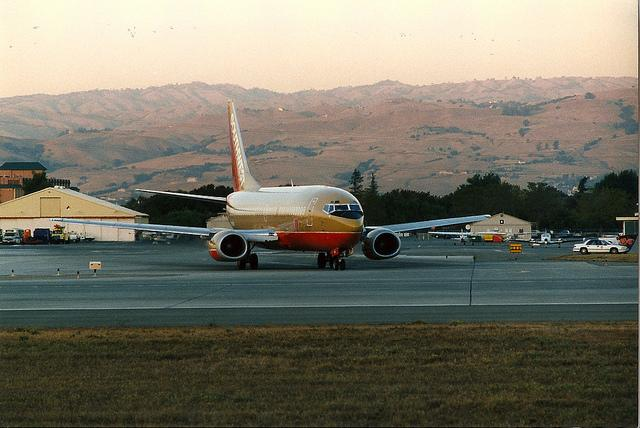What is the plane doing that requires it to be perpendicular to the runway? Please explain your reasoning. taxiing. A plane is on a runway and is turned towards the side. the wheels of the plane are turned. 